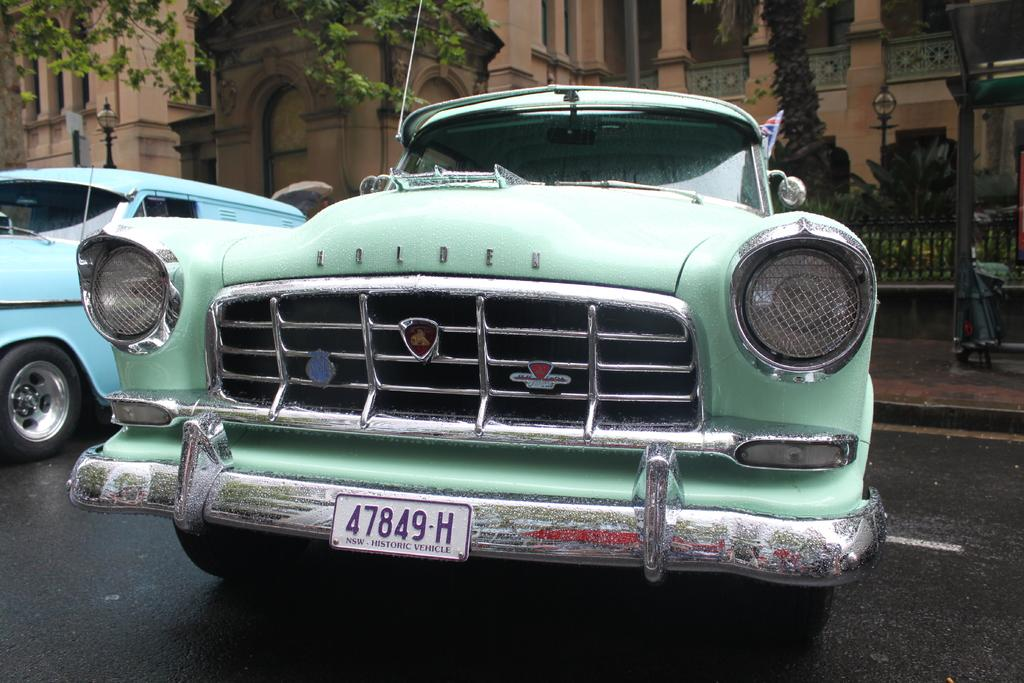What type of vehicles can be seen on the road in the image? There are cars on the road in the image. What structures are visible in the image? There are buildings in the image. What type of natural elements can be seen in the image? There are trees in the image. What type of barrier is present in the image? There is a fence in the image. What type of vertical structures can be seen in the image? There are poles in the image. What type of symbol or emblem is present in the image? There is a flag in the image. How many women are sitting on the dock in the image? There is no dock present in the image, and therefore no women can be found sitting on it. 